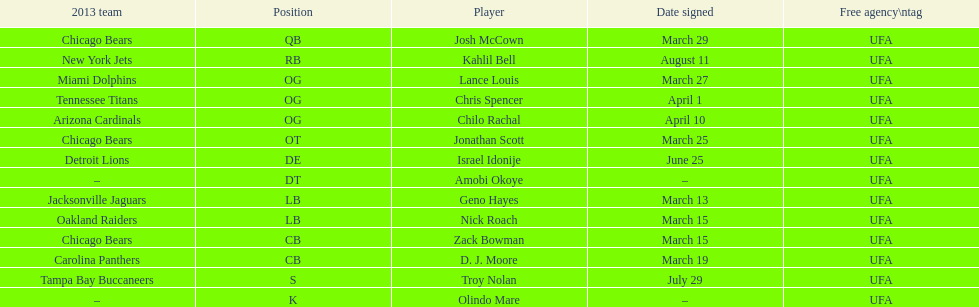His/her first name is the same name as a country. Israel Idonije. 